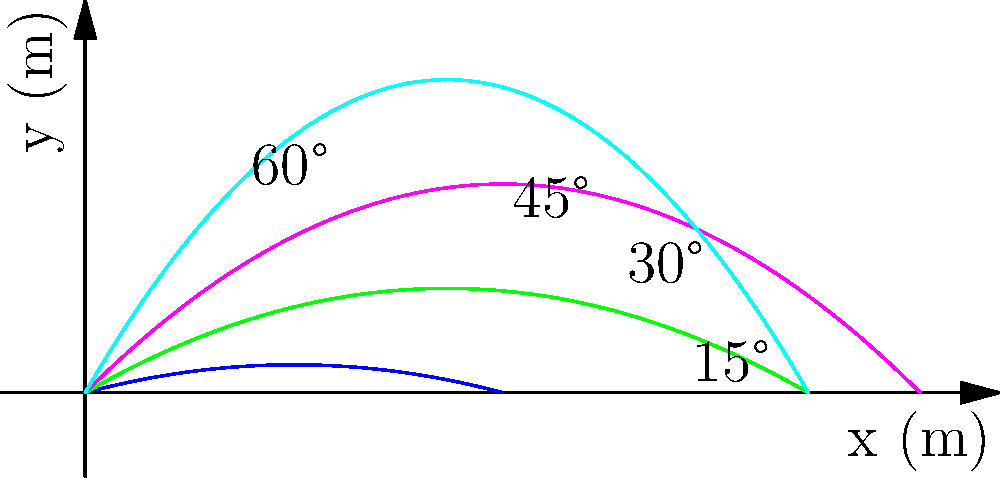The graph shows the trajectories of projectiles launched at different angles (15°, 30°, 45°, and 60°) with the same initial velocity of 50 m/s. Based on the graph, which angle of launch results in the maximum horizontal distance traveled by the projectile? To determine the angle that results in the maximum horizontal distance, we need to analyze the trajectories:

1. The horizontal distance traveled by a projectile is determined by where the trajectory intersects the x-axis (y = 0).

2. From the graph, we can observe that:
   - The 15° trajectory (bottom curve) travels far but not the farthest.
   - The 60° trajectory (top curve) reaches the highest point but falls short horizontally.
   - The 30° and 45° trajectories travel further horizontally than 15° and 60°.

3. Comparing 30° and 45°:
   - The 45° trajectory appears to travel slightly further horizontally than the 30° trajectory.

4. This observation aligns with the theoretical result that, in the absence of air resistance, a 45° launch angle maximizes the horizontal distance for a given initial velocity.

5. The equation for the horizontal distance (R) is:
   $$ R = \frac{v_0^2 \sin(2\theta)}{g} $$
   where $v_0$ is the initial velocity, $\theta$ is the launch angle, and $g$ is the acceleration due to gravity.

6. The maximum value of $\sin(2\theta)$ occurs when $2\theta = 90°$, or $\theta = 45°$.

Therefore, based on both the graphical representation and theoretical considerations, the 45° launch angle results in the maximum horizontal distance traveled by the projectile.
Answer: 45° 